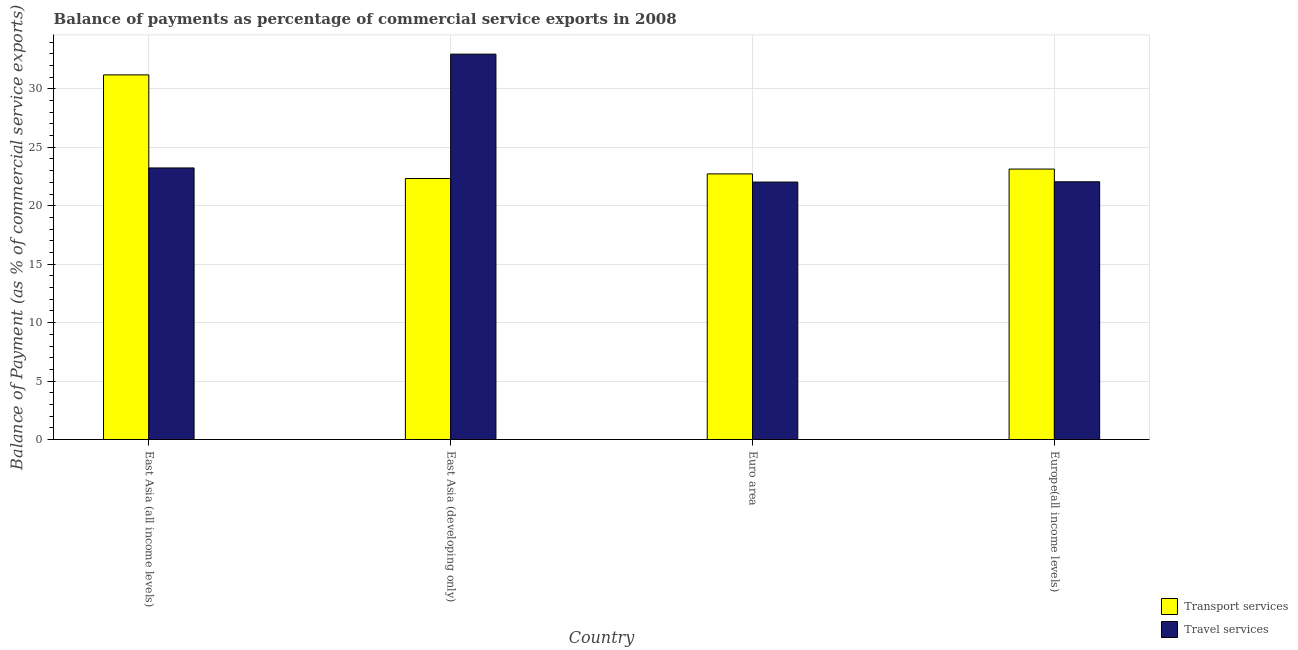How many different coloured bars are there?
Give a very brief answer. 2. Are the number of bars on each tick of the X-axis equal?
Provide a succinct answer. Yes. How many bars are there on the 3rd tick from the right?
Your answer should be compact. 2. What is the label of the 2nd group of bars from the left?
Your response must be concise. East Asia (developing only). What is the balance of payments of transport services in East Asia (developing only)?
Your response must be concise. 22.33. Across all countries, what is the maximum balance of payments of transport services?
Offer a terse response. 31.2. Across all countries, what is the minimum balance of payments of travel services?
Offer a very short reply. 22.03. In which country was the balance of payments of transport services maximum?
Offer a very short reply. East Asia (all income levels). In which country was the balance of payments of transport services minimum?
Ensure brevity in your answer.  East Asia (developing only). What is the total balance of payments of transport services in the graph?
Offer a terse response. 99.39. What is the difference between the balance of payments of travel services in Euro area and that in Europe(all income levels)?
Your answer should be compact. -0.02. What is the difference between the balance of payments of transport services in East Asia (developing only) and the balance of payments of travel services in Europe(all income levels)?
Make the answer very short. 0.28. What is the average balance of payments of travel services per country?
Give a very brief answer. 25.07. What is the difference between the balance of payments of transport services and balance of payments of travel services in Europe(all income levels)?
Keep it short and to the point. 1.09. In how many countries, is the balance of payments of travel services greater than 26 %?
Your answer should be compact. 1. What is the ratio of the balance of payments of transport services in East Asia (all income levels) to that in Euro area?
Your answer should be compact. 1.37. Is the balance of payments of transport services in East Asia (developing only) less than that in Euro area?
Keep it short and to the point. Yes. What is the difference between the highest and the second highest balance of payments of transport services?
Provide a short and direct response. 8.06. What is the difference between the highest and the lowest balance of payments of travel services?
Your answer should be very brief. 10.94. In how many countries, is the balance of payments of transport services greater than the average balance of payments of transport services taken over all countries?
Make the answer very short. 1. What does the 2nd bar from the left in East Asia (all income levels) represents?
Your answer should be compact. Travel services. What does the 1st bar from the right in Europe(all income levels) represents?
Offer a very short reply. Travel services. Are all the bars in the graph horizontal?
Your answer should be very brief. No. What is the difference between two consecutive major ticks on the Y-axis?
Provide a succinct answer. 5. Are the values on the major ticks of Y-axis written in scientific E-notation?
Your response must be concise. No. Where does the legend appear in the graph?
Your answer should be compact. Bottom right. How many legend labels are there?
Keep it short and to the point. 2. How are the legend labels stacked?
Your answer should be compact. Vertical. What is the title of the graph?
Keep it short and to the point. Balance of payments as percentage of commercial service exports in 2008. What is the label or title of the X-axis?
Your answer should be compact. Country. What is the label or title of the Y-axis?
Offer a terse response. Balance of Payment (as % of commercial service exports). What is the Balance of Payment (as % of commercial service exports) of Transport services in East Asia (all income levels)?
Ensure brevity in your answer.  31.2. What is the Balance of Payment (as % of commercial service exports) of Travel services in East Asia (all income levels)?
Make the answer very short. 23.23. What is the Balance of Payment (as % of commercial service exports) in Transport services in East Asia (developing only)?
Keep it short and to the point. 22.33. What is the Balance of Payment (as % of commercial service exports) in Travel services in East Asia (developing only)?
Give a very brief answer. 32.97. What is the Balance of Payment (as % of commercial service exports) in Transport services in Euro area?
Make the answer very short. 22.73. What is the Balance of Payment (as % of commercial service exports) of Travel services in Euro area?
Give a very brief answer. 22.03. What is the Balance of Payment (as % of commercial service exports) of Transport services in Europe(all income levels)?
Give a very brief answer. 23.14. What is the Balance of Payment (as % of commercial service exports) of Travel services in Europe(all income levels)?
Keep it short and to the point. 22.05. Across all countries, what is the maximum Balance of Payment (as % of commercial service exports) in Transport services?
Give a very brief answer. 31.2. Across all countries, what is the maximum Balance of Payment (as % of commercial service exports) in Travel services?
Ensure brevity in your answer.  32.97. Across all countries, what is the minimum Balance of Payment (as % of commercial service exports) in Transport services?
Your answer should be compact. 22.33. Across all countries, what is the minimum Balance of Payment (as % of commercial service exports) of Travel services?
Ensure brevity in your answer.  22.03. What is the total Balance of Payment (as % of commercial service exports) of Transport services in the graph?
Offer a terse response. 99.39. What is the total Balance of Payment (as % of commercial service exports) in Travel services in the graph?
Give a very brief answer. 100.28. What is the difference between the Balance of Payment (as % of commercial service exports) of Transport services in East Asia (all income levels) and that in East Asia (developing only)?
Offer a very short reply. 8.87. What is the difference between the Balance of Payment (as % of commercial service exports) in Travel services in East Asia (all income levels) and that in East Asia (developing only)?
Make the answer very short. -9.74. What is the difference between the Balance of Payment (as % of commercial service exports) of Transport services in East Asia (all income levels) and that in Euro area?
Make the answer very short. 8.47. What is the difference between the Balance of Payment (as % of commercial service exports) in Travel services in East Asia (all income levels) and that in Euro area?
Offer a terse response. 1.21. What is the difference between the Balance of Payment (as % of commercial service exports) in Transport services in East Asia (all income levels) and that in Europe(all income levels)?
Give a very brief answer. 8.06. What is the difference between the Balance of Payment (as % of commercial service exports) in Travel services in East Asia (all income levels) and that in Europe(all income levels)?
Ensure brevity in your answer.  1.18. What is the difference between the Balance of Payment (as % of commercial service exports) in Transport services in East Asia (developing only) and that in Euro area?
Provide a succinct answer. -0.4. What is the difference between the Balance of Payment (as % of commercial service exports) in Travel services in East Asia (developing only) and that in Euro area?
Your answer should be very brief. 10.94. What is the difference between the Balance of Payment (as % of commercial service exports) of Transport services in East Asia (developing only) and that in Europe(all income levels)?
Your response must be concise. -0.81. What is the difference between the Balance of Payment (as % of commercial service exports) in Travel services in East Asia (developing only) and that in Europe(all income levels)?
Offer a terse response. 10.92. What is the difference between the Balance of Payment (as % of commercial service exports) of Transport services in Euro area and that in Europe(all income levels)?
Make the answer very short. -0.41. What is the difference between the Balance of Payment (as % of commercial service exports) of Travel services in Euro area and that in Europe(all income levels)?
Your answer should be compact. -0.02. What is the difference between the Balance of Payment (as % of commercial service exports) in Transport services in East Asia (all income levels) and the Balance of Payment (as % of commercial service exports) in Travel services in East Asia (developing only)?
Give a very brief answer. -1.77. What is the difference between the Balance of Payment (as % of commercial service exports) in Transport services in East Asia (all income levels) and the Balance of Payment (as % of commercial service exports) in Travel services in Euro area?
Your answer should be compact. 9.17. What is the difference between the Balance of Payment (as % of commercial service exports) of Transport services in East Asia (all income levels) and the Balance of Payment (as % of commercial service exports) of Travel services in Europe(all income levels)?
Offer a terse response. 9.15. What is the difference between the Balance of Payment (as % of commercial service exports) in Transport services in East Asia (developing only) and the Balance of Payment (as % of commercial service exports) in Travel services in Euro area?
Your answer should be compact. 0.3. What is the difference between the Balance of Payment (as % of commercial service exports) of Transport services in East Asia (developing only) and the Balance of Payment (as % of commercial service exports) of Travel services in Europe(all income levels)?
Make the answer very short. 0.28. What is the difference between the Balance of Payment (as % of commercial service exports) of Transport services in Euro area and the Balance of Payment (as % of commercial service exports) of Travel services in Europe(all income levels)?
Offer a very short reply. 0.68. What is the average Balance of Payment (as % of commercial service exports) in Transport services per country?
Your answer should be compact. 24.85. What is the average Balance of Payment (as % of commercial service exports) of Travel services per country?
Ensure brevity in your answer.  25.07. What is the difference between the Balance of Payment (as % of commercial service exports) in Transport services and Balance of Payment (as % of commercial service exports) in Travel services in East Asia (all income levels)?
Ensure brevity in your answer.  7.96. What is the difference between the Balance of Payment (as % of commercial service exports) in Transport services and Balance of Payment (as % of commercial service exports) in Travel services in East Asia (developing only)?
Keep it short and to the point. -10.64. What is the difference between the Balance of Payment (as % of commercial service exports) in Transport services and Balance of Payment (as % of commercial service exports) in Travel services in Euro area?
Give a very brief answer. 0.7. What is the difference between the Balance of Payment (as % of commercial service exports) in Transport services and Balance of Payment (as % of commercial service exports) in Travel services in Europe(all income levels)?
Give a very brief answer. 1.09. What is the ratio of the Balance of Payment (as % of commercial service exports) in Transport services in East Asia (all income levels) to that in East Asia (developing only)?
Make the answer very short. 1.4. What is the ratio of the Balance of Payment (as % of commercial service exports) of Travel services in East Asia (all income levels) to that in East Asia (developing only)?
Your response must be concise. 0.7. What is the ratio of the Balance of Payment (as % of commercial service exports) in Transport services in East Asia (all income levels) to that in Euro area?
Offer a very short reply. 1.37. What is the ratio of the Balance of Payment (as % of commercial service exports) in Travel services in East Asia (all income levels) to that in Euro area?
Provide a succinct answer. 1.05. What is the ratio of the Balance of Payment (as % of commercial service exports) of Transport services in East Asia (all income levels) to that in Europe(all income levels)?
Your answer should be very brief. 1.35. What is the ratio of the Balance of Payment (as % of commercial service exports) of Travel services in East Asia (all income levels) to that in Europe(all income levels)?
Offer a very short reply. 1.05. What is the ratio of the Balance of Payment (as % of commercial service exports) of Transport services in East Asia (developing only) to that in Euro area?
Keep it short and to the point. 0.98. What is the ratio of the Balance of Payment (as % of commercial service exports) in Travel services in East Asia (developing only) to that in Euro area?
Your answer should be compact. 1.5. What is the ratio of the Balance of Payment (as % of commercial service exports) in Travel services in East Asia (developing only) to that in Europe(all income levels)?
Make the answer very short. 1.5. What is the ratio of the Balance of Payment (as % of commercial service exports) in Transport services in Euro area to that in Europe(all income levels)?
Give a very brief answer. 0.98. What is the ratio of the Balance of Payment (as % of commercial service exports) of Travel services in Euro area to that in Europe(all income levels)?
Keep it short and to the point. 1. What is the difference between the highest and the second highest Balance of Payment (as % of commercial service exports) of Transport services?
Your answer should be very brief. 8.06. What is the difference between the highest and the second highest Balance of Payment (as % of commercial service exports) of Travel services?
Your response must be concise. 9.74. What is the difference between the highest and the lowest Balance of Payment (as % of commercial service exports) of Transport services?
Offer a terse response. 8.87. What is the difference between the highest and the lowest Balance of Payment (as % of commercial service exports) in Travel services?
Make the answer very short. 10.94. 